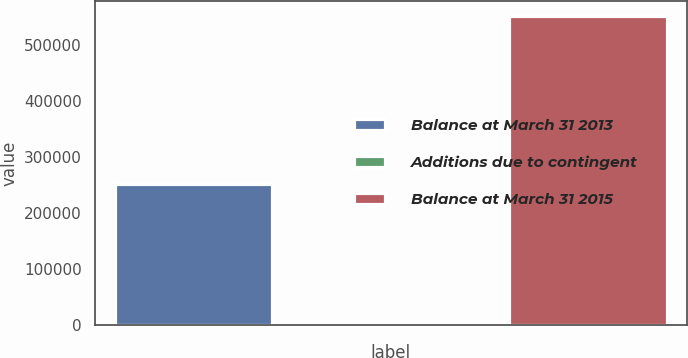Convert chart to OTSL. <chart><loc_0><loc_0><loc_500><loc_500><bar_chart><fcel>Balance at March 31 2013<fcel>Additions due to contingent<fcel>Balance at March 31 2015<nl><fcel>252148<fcel>111<fcel>552071<nl></chart> 